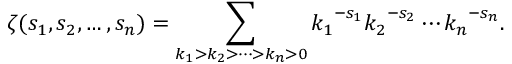Convert formula to latex. <formula><loc_0><loc_0><loc_500><loc_500>\zeta ( s _ { 1 } , s _ { 2 } , \dots , s _ { n } ) = \sum _ { k _ { 1 } > k _ { 2 } > \cdots > k _ { n } > 0 } { k _ { 1 } } ^ { - s _ { 1 } } { k _ { 2 } } ^ { - s _ { 2 } } \cdots { k _ { n } } ^ { - s _ { n } } .</formula> 